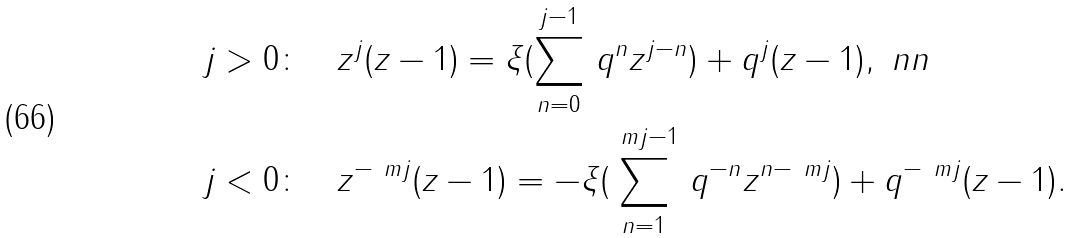<formula> <loc_0><loc_0><loc_500><loc_500>& j > 0 \colon \quad z ^ { j } ( z - 1 ) = \xi ( \sum _ { n = 0 } ^ { j - 1 } \, q ^ { n } z ^ { j - n } ) + q ^ { j } ( z - 1 ) , \ n n \\ & j < 0 \colon \quad z ^ { - \ m j } ( z - 1 ) = - \xi ( \sum _ { n = 1 } ^ { \ m j - 1 } \, q ^ { - n } z ^ { n - \ m j } ) + q ^ { - \ m j } ( z - 1 ) .</formula> 